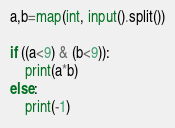Convert code to text. <code><loc_0><loc_0><loc_500><loc_500><_Python_>a,b=map(int, input().split())

if ((a<9) & (b<9)):
    print(a*b)
else:
    print(-1)
</code> 